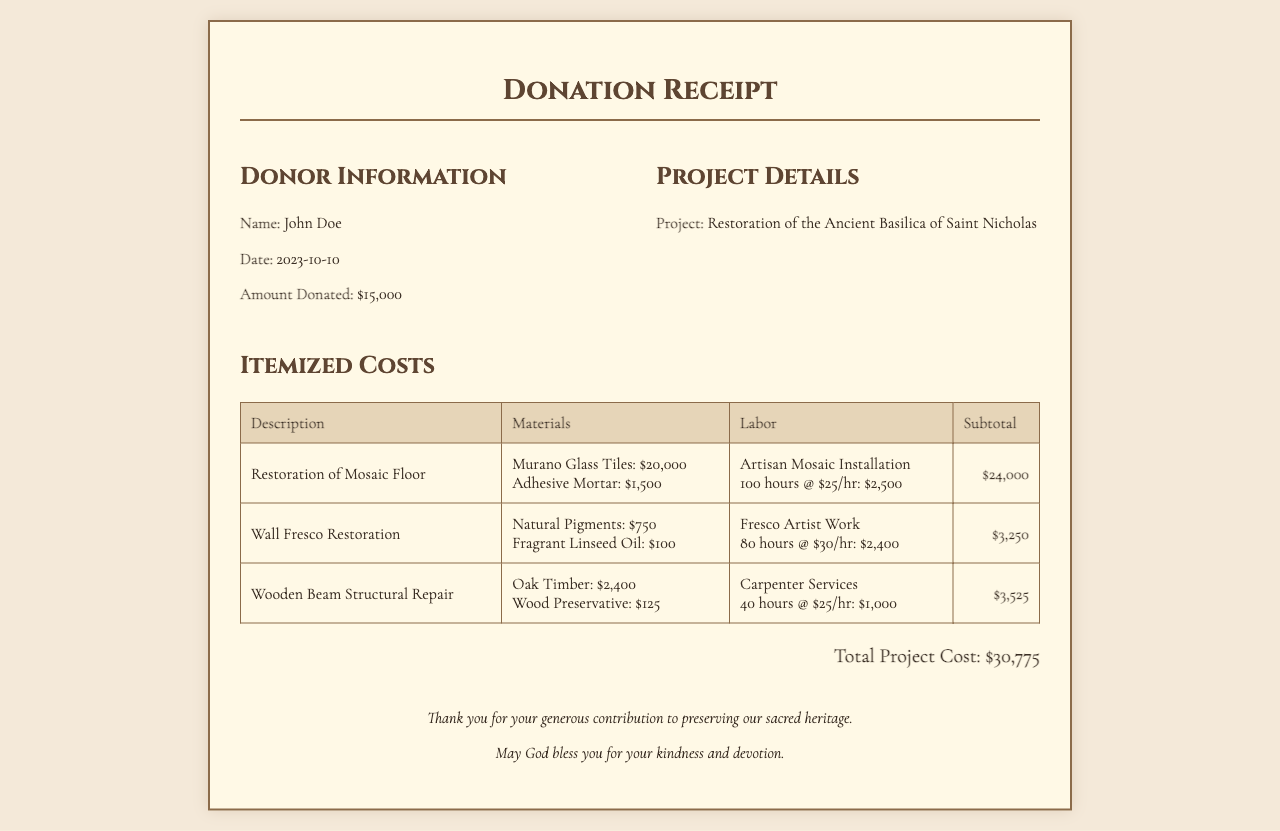what is the donor's name? The donor's name is specified in the donor information section of the receipt.
Answer: John Doe what is the donation amount? The amount donated is listed under the donor information section of the receipt.
Answer: $15,000 what is the project title? The project title is mentioned in the project details section of the receipt.
Answer: Restoration of the Ancient Basilica of Saint Nicholas how much was spent on Murano Glass Tiles? The cost for Murano Glass Tiles is given in the itemized costs table under the Restoration of Mosaic Floor section.
Answer: $20,000 what is the total project cost? The total project cost is indicated at the bottom of the receipt after itemized costs.
Answer: $30,775 how many hours were spent on the Fresco Artist's work? The number of hours worked by the Fresco Artist is specified in the labor section of the Wall Fresco Restoration entry.
Answer: 80 hours which material was used for the Wooden Beam Structural Repair? The materials used are listed in the respective entry of the itemized costs section.
Answer: Oak Timber what is the hourly rate for the Artisan Mosaic Installation? The hourly rate is mentioned in the labor details for the restoration of the mosaic floor.
Answer: $25/hr how much did the Wood Preservative cost? The cost of the Wood Preservative is provided in the itemized costs table.
Answer: $125 